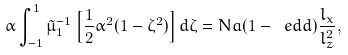Convert formula to latex. <formula><loc_0><loc_0><loc_500><loc_500>\alpha \int ^ { 1 } _ { - 1 } \tilde { \mu } _ { 1 } ^ { - 1 } \left [ \frac { 1 } { 2 } \alpha ^ { 2 } ( 1 - \zeta ^ { 2 } ) \right ] d \zeta = N a ( 1 - \ e d d ) \frac { l _ { x } } { l _ { z } ^ { 2 } } ,</formula> 